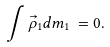<formula> <loc_0><loc_0><loc_500><loc_500>\int \vec { \rho } _ { 1 } d m _ { 1 } \, = 0 .</formula> 